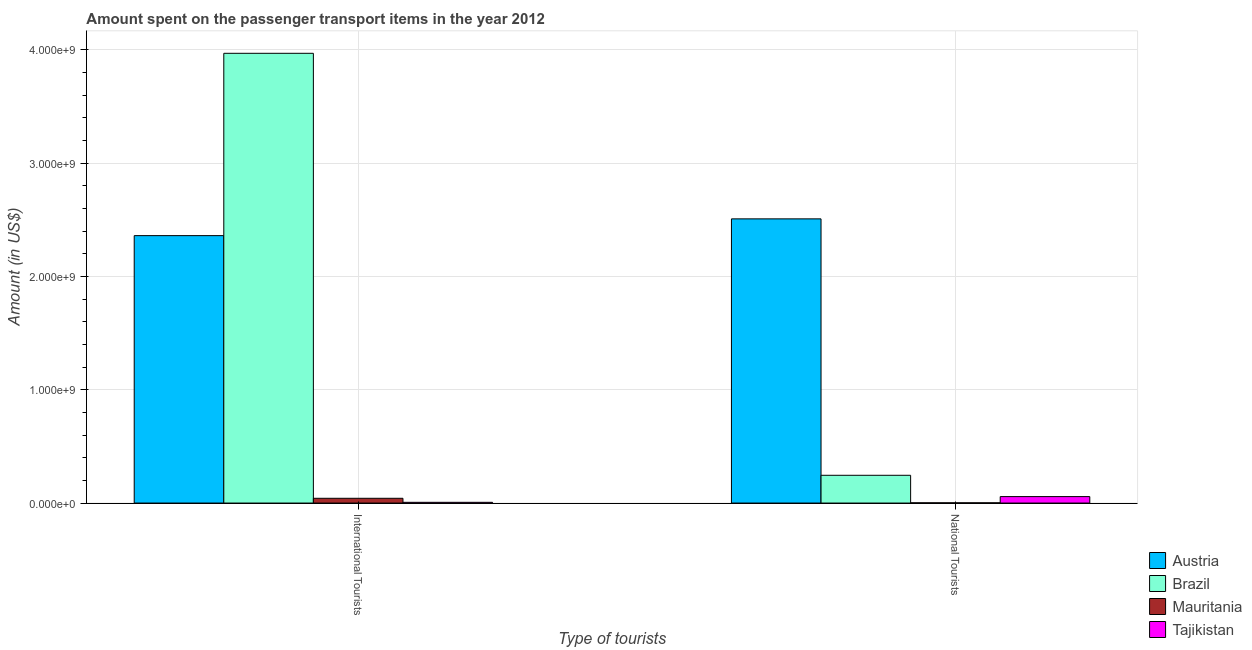How many different coloured bars are there?
Provide a short and direct response. 4. Are the number of bars per tick equal to the number of legend labels?
Your response must be concise. Yes. What is the label of the 1st group of bars from the left?
Provide a short and direct response. International Tourists. What is the amount spent on transport items of international tourists in Mauritania?
Ensure brevity in your answer.  4.20e+07. Across all countries, what is the maximum amount spent on transport items of international tourists?
Make the answer very short. 3.97e+09. Across all countries, what is the minimum amount spent on transport items of international tourists?
Ensure brevity in your answer.  6.50e+06. In which country was the amount spent on transport items of international tourists minimum?
Provide a short and direct response. Tajikistan. What is the total amount spent on transport items of national tourists in the graph?
Give a very brief answer. 2.81e+09. What is the difference between the amount spent on transport items of national tourists in Brazil and that in Mauritania?
Make the answer very short. 2.43e+08. What is the difference between the amount spent on transport items of international tourists in Mauritania and the amount spent on transport items of national tourists in Brazil?
Offer a terse response. -2.03e+08. What is the average amount spent on transport items of national tourists per country?
Provide a short and direct response. 7.03e+08. What is the difference between the amount spent on transport items of national tourists and amount spent on transport items of international tourists in Brazil?
Offer a very short reply. -3.72e+09. What is the ratio of the amount spent on transport items of national tourists in Mauritania to that in Tajikistan?
Your answer should be compact. 0.04. Is the amount spent on transport items of international tourists in Mauritania less than that in Tajikistan?
Offer a very short reply. No. In how many countries, is the amount spent on transport items of international tourists greater than the average amount spent on transport items of international tourists taken over all countries?
Ensure brevity in your answer.  2. What does the 4th bar from the left in International Tourists represents?
Your answer should be compact. Tajikistan. What does the 3rd bar from the right in International Tourists represents?
Offer a very short reply. Brazil. Are all the bars in the graph horizontal?
Your answer should be very brief. No. How many countries are there in the graph?
Keep it short and to the point. 4. Does the graph contain any zero values?
Your response must be concise. No. Does the graph contain grids?
Offer a very short reply. Yes. How many legend labels are there?
Keep it short and to the point. 4. What is the title of the graph?
Your response must be concise. Amount spent on the passenger transport items in the year 2012. Does "Slovak Republic" appear as one of the legend labels in the graph?
Provide a succinct answer. No. What is the label or title of the X-axis?
Your response must be concise. Type of tourists. What is the label or title of the Y-axis?
Offer a very short reply. Amount (in US$). What is the Amount (in US$) in Austria in International Tourists?
Ensure brevity in your answer.  2.36e+09. What is the Amount (in US$) in Brazil in International Tourists?
Make the answer very short. 3.97e+09. What is the Amount (in US$) of Mauritania in International Tourists?
Ensure brevity in your answer.  4.20e+07. What is the Amount (in US$) of Tajikistan in International Tourists?
Offer a terse response. 6.50e+06. What is the Amount (in US$) in Austria in National Tourists?
Provide a succinct answer. 2.51e+09. What is the Amount (in US$) of Brazil in National Tourists?
Make the answer very short. 2.45e+08. What is the Amount (in US$) of Mauritania in National Tourists?
Provide a succinct answer. 2.00e+06. What is the Amount (in US$) in Tajikistan in National Tourists?
Offer a terse response. 5.70e+07. Across all Type of tourists, what is the maximum Amount (in US$) in Austria?
Your answer should be compact. 2.51e+09. Across all Type of tourists, what is the maximum Amount (in US$) of Brazil?
Your response must be concise. 3.97e+09. Across all Type of tourists, what is the maximum Amount (in US$) in Mauritania?
Ensure brevity in your answer.  4.20e+07. Across all Type of tourists, what is the maximum Amount (in US$) in Tajikistan?
Keep it short and to the point. 5.70e+07. Across all Type of tourists, what is the minimum Amount (in US$) in Austria?
Your answer should be compact. 2.36e+09. Across all Type of tourists, what is the minimum Amount (in US$) of Brazil?
Provide a succinct answer. 2.45e+08. Across all Type of tourists, what is the minimum Amount (in US$) of Tajikistan?
Provide a succinct answer. 6.50e+06. What is the total Amount (in US$) in Austria in the graph?
Ensure brevity in your answer.  4.87e+09. What is the total Amount (in US$) of Brazil in the graph?
Keep it short and to the point. 4.21e+09. What is the total Amount (in US$) in Mauritania in the graph?
Make the answer very short. 4.40e+07. What is the total Amount (in US$) of Tajikistan in the graph?
Keep it short and to the point. 6.35e+07. What is the difference between the Amount (in US$) in Austria in International Tourists and that in National Tourists?
Make the answer very short. -1.48e+08. What is the difference between the Amount (in US$) of Brazil in International Tourists and that in National Tourists?
Your response must be concise. 3.72e+09. What is the difference between the Amount (in US$) of Mauritania in International Tourists and that in National Tourists?
Ensure brevity in your answer.  4.00e+07. What is the difference between the Amount (in US$) of Tajikistan in International Tourists and that in National Tourists?
Give a very brief answer. -5.05e+07. What is the difference between the Amount (in US$) in Austria in International Tourists and the Amount (in US$) in Brazil in National Tourists?
Ensure brevity in your answer.  2.12e+09. What is the difference between the Amount (in US$) in Austria in International Tourists and the Amount (in US$) in Mauritania in National Tourists?
Give a very brief answer. 2.36e+09. What is the difference between the Amount (in US$) in Austria in International Tourists and the Amount (in US$) in Tajikistan in National Tourists?
Provide a succinct answer. 2.30e+09. What is the difference between the Amount (in US$) in Brazil in International Tourists and the Amount (in US$) in Mauritania in National Tourists?
Make the answer very short. 3.97e+09. What is the difference between the Amount (in US$) of Brazil in International Tourists and the Amount (in US$) of Tajikistan in National Tourists?
Make the answer very short. 3.91e+09. What is the difference between the Amount (in US$) of Mauritania in International Tourists and the Amount (in US$) of Tajikistan in National Tourists?
Give a very brief answer. -1.50e+07. What is the average Amount (in US$) in Austria per Type of tourists?
Offer a very short reply. 2.43e+09. What is the average Amount (in US$) of Brazil per Type of tourists?
Offer a terse response. 2.11e+09. What is the average Amount (in US$) of Mauritania per Type of tourists?
Provide a short and direct response. 2.20e+07. What is the average Amount (in US$) in Tajikistan per Type of tourists?
Your answer should be very brief. 3.18e+07. What is the difference between the Amount (in US$) of Austria and Amount (in US$) of Brazil in International Tourists?
Your response must be concise. -1.61e+09. What is the difference between the Amount (in US$) in Austria and Amount (in US$) in Mauritania in International Tourists?
Offer a terse response. 2.32e+09. What is the difference between the Amount (in US$) in Austria and Amount (in US$) in Tajikistan in International Tourists?
Offer a very short reply. 2.35e+09. What is the difference between the Amount (in US$) of Brazil and Amount (in US$) of Mauritania in International Tourists?
Your response must be concise. 3.93e+09. What is the difference between the Amount (in US$) in Brazil and Amount (in US$) in Tajikistan in International Tourists?
Offer a terse response. 3.96e+09. What is the difference between the Amount (in US$) of Mauritania and Amount (in US$) of Tajikistan in International Tourists?
Keep it short and to the point. 3.55e+07. What is the difference between the Amount (in US$) in Austria and Amount (in US$) in Brazil in National Tourists?
Offer a very short reply. 2.26e+09. What is the difference between the Amount (in US$) of Austria and Amount (in US$) of Mauritania in National Tourists?
Keep it short and to the point. 2.51e+09. What is the difference between the Amount (in US$) of Austria and Amount (in US$) of Tajikistan in National Tourists?
Ensure brevity in your answer.  2.45e+09. What is the difference between the Amount (in US$) of Brazil and Amount (in US$) of Mauritania in National Tourists?
Provide a succinct answer. 2.43e+08. What is the difference between the Amount (in US$) of Brazil and Amount (in US$) of Tajikistan in National Tourists?
Ensure brevity in your answer.  1.88e+08. What is the difference between the Amount (in US$) in Mauritania and Amount (in US$) in Tajikistan in National Tourists?
Ensure brevity in your answer.  -5.50e+07. What is the ratio of the Amount (in US$) of Austria in International Tourists to that in National Tourists?
Offer a terse response. 0.94. What is the ratio of the Amount (in US$) of Tajikistan in International Tourists to that in National Tourists?
Offer a terse response. 0.11. What is the difference between the highest and the second highest Amount (in US$) in Austria?
Offer a terse response. 1.48e+08. What is the difference between the highest and the second highest Amount (in US$) of Brazil?
Make the answer very short. 3.72e+09. What is the difference between the highest and the second highest Amount (in US$) of Mauritania?
Keep it short and to the point. 4.00e+07. What is the difference between the highest and the second highest Amount (in US$) of Tajikistan?
Ensure brevity in your answer.  5.05e+07. What is the difference between the highest and the lowest Amount (in US$) in Austria?
Ensure brevity in your answer.  1.48e+08. What is the difference between the highest and the lowest Amount (in US$) of Brazil?
Provide a succinct answer. 3.72e+09. What is the difference between the highest and the lowest Amount (in US$) in Mauritania?
Your answer should be compact. 4.00e+07. What is the difference between the highest and the lowest Amount (in US$) of Tajikistan?
Your answer should be compact. 5.05e+07. 